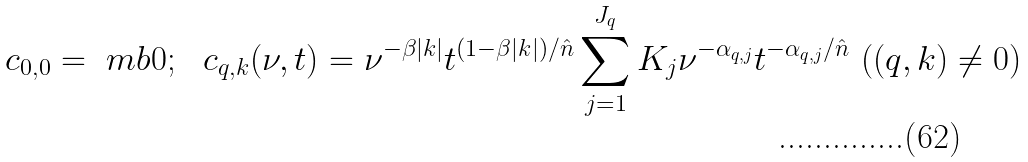Convert formula to latex. <formula><loc_0><loc_0><loc_500><loc_500>c _ { 0 , 0 } = \ m b 0 ; \ \ { c } _ { { q } , { k } } ( \nu , t ) = \nu ^ { - \beta | { k } | } t ^ { ( 1 - \beta | { k } | ) / { \hat { n } } } \sum _ { j = 1 } ^ { J _ { q } } K _ { j } \nu ^ { - \alpha _ { { q } , j } } t ^ { - \alpha _ { { q } , j } / { \hat { n } } } \ ( ( q , k ) \ne 0 )</formula> 